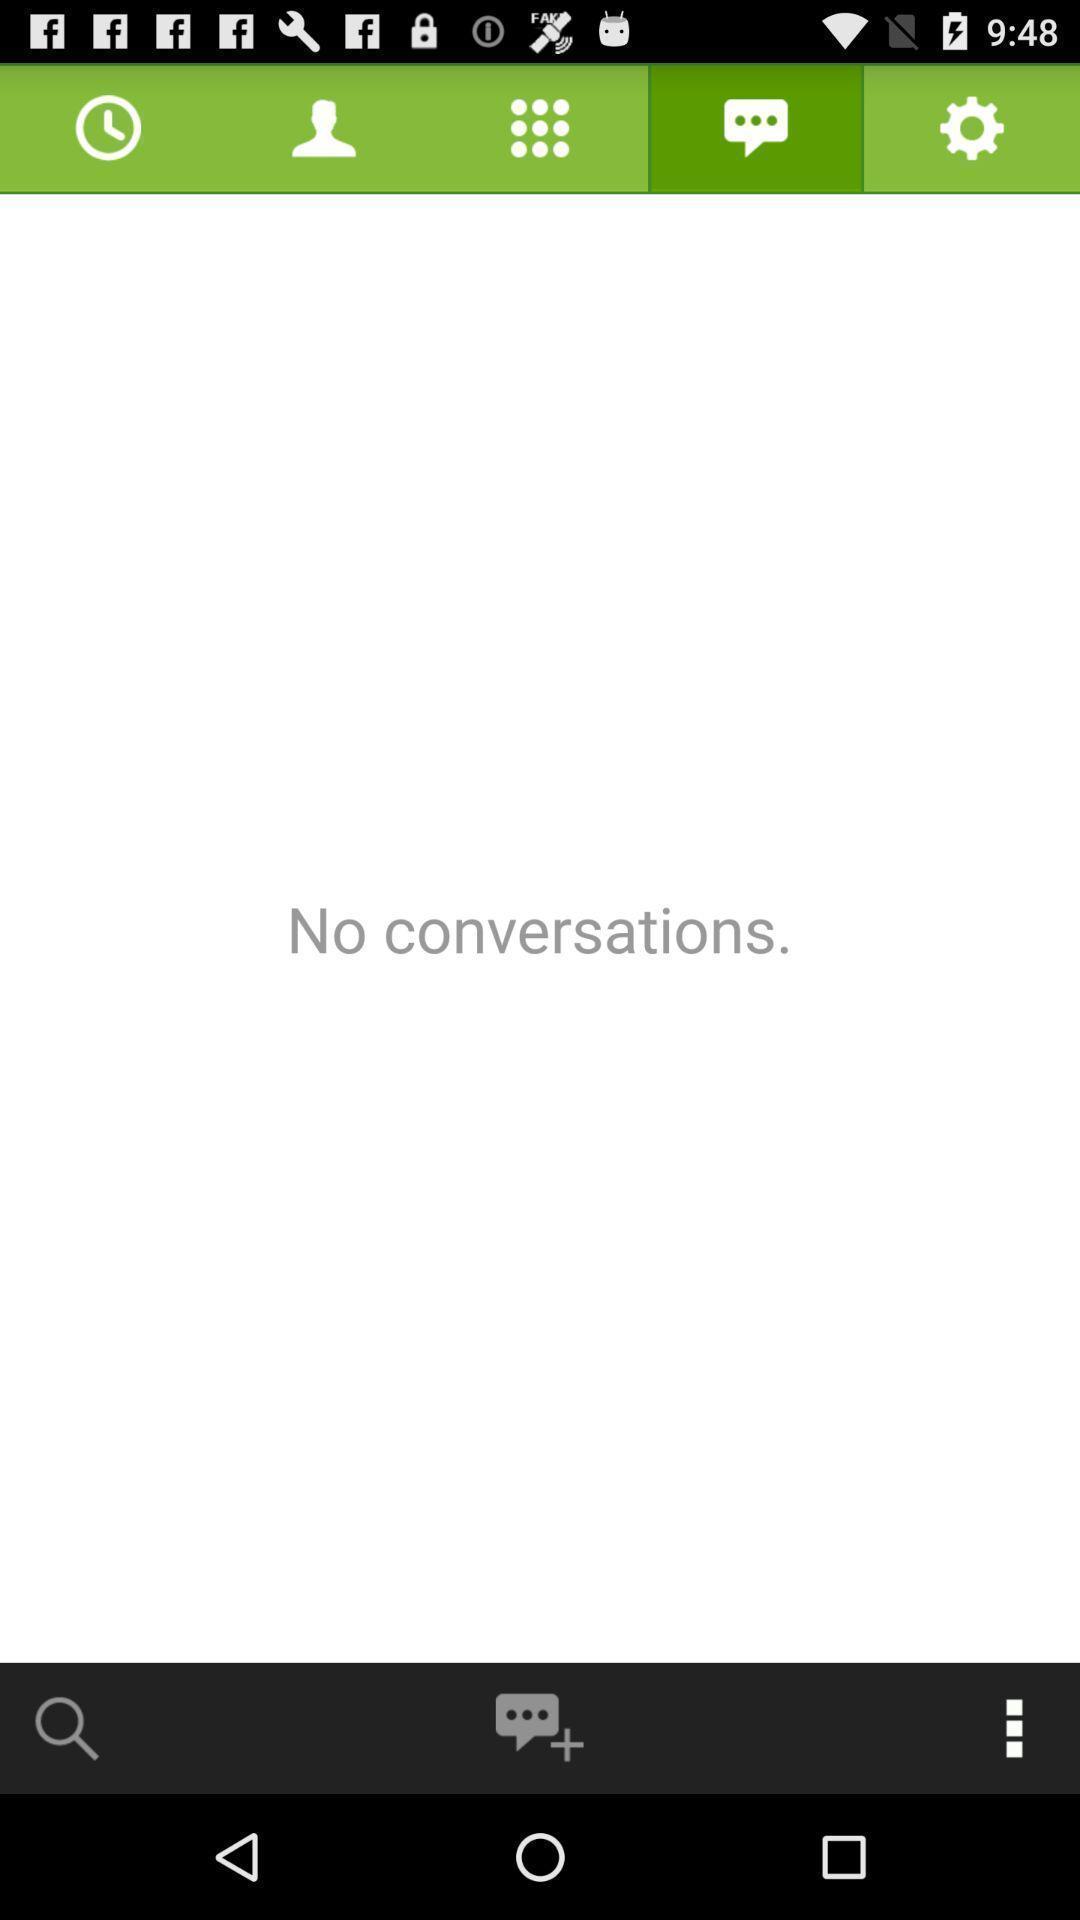Tell me about the visual elements in this screen capture. Screen shows multiple options in a call application. 